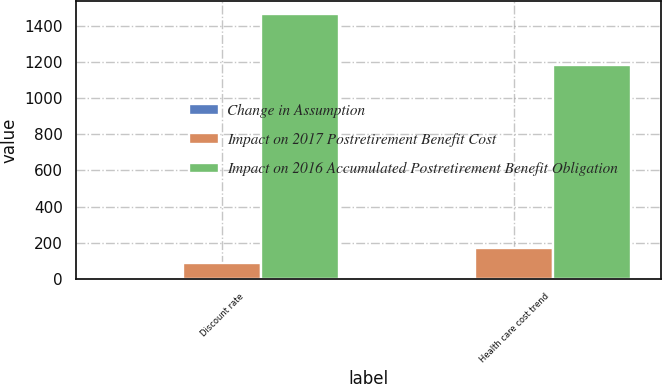Convert chart. <chart><loc_0><loc_0><loc_500><loc_500><stacked_bar_chart><ecel><fcel>Discount rate<fcel>Health care cost trend<nl><fcel>Change in Assumption<fcel>0.25<fcel>0.25<nl><fcel>Impact on 2017 Postretirement Benefit Cost<fcel>85<fcel>168<nl><fcel>Impact on 2016 Accumulated Postretirement Benefit Obligation<fcel>1465<fcel>1185<nl></chart> 